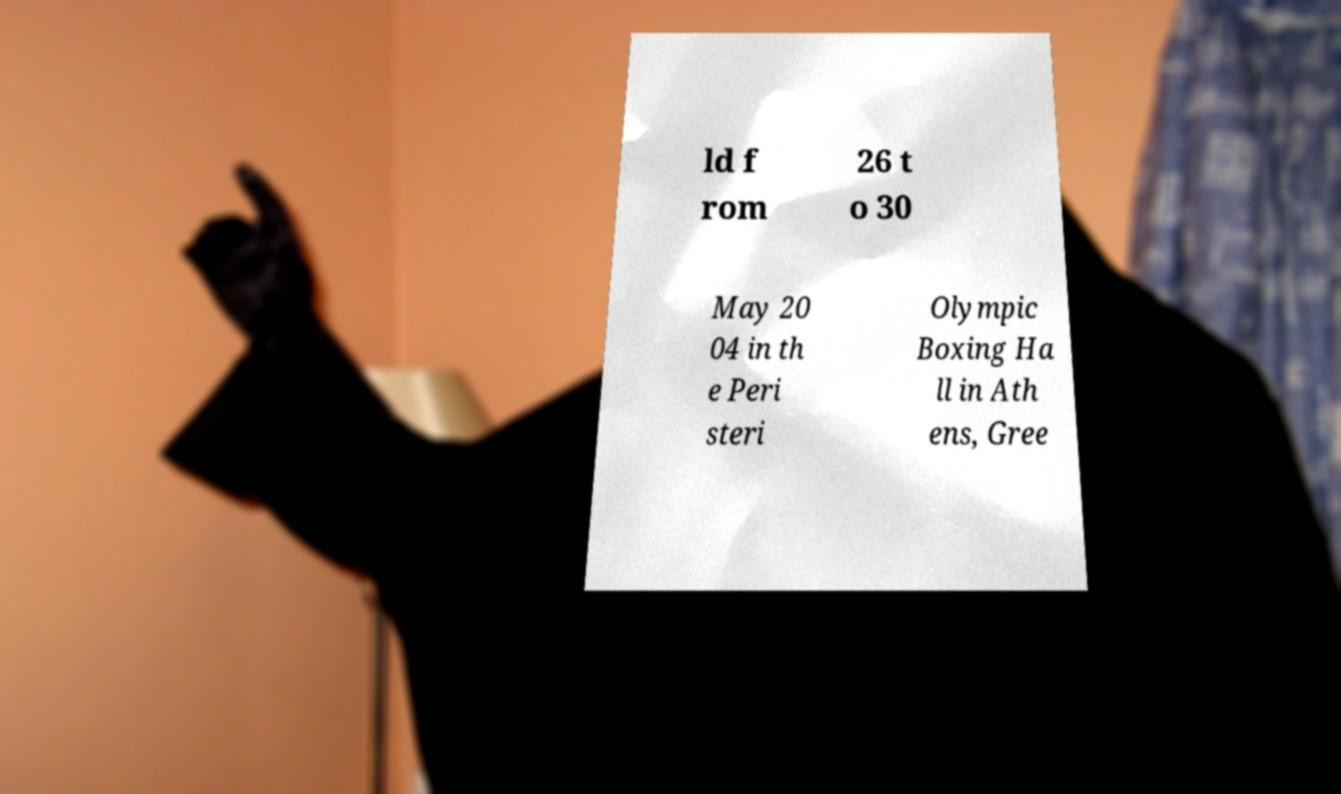Could you extract and type out the text from this image? ld f rom 26 t o 30 May 20 04 in th e Peri steri Olympic Boxing Ha ll in Ath ens, Gree 